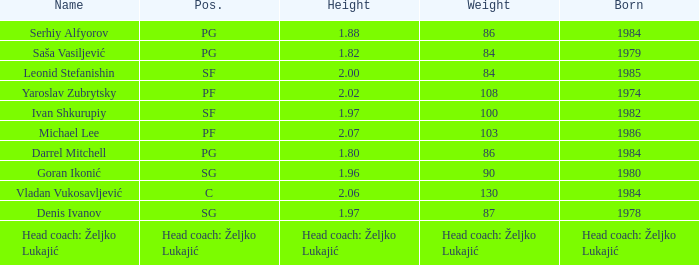Which position did Michael Lee play? PF. 